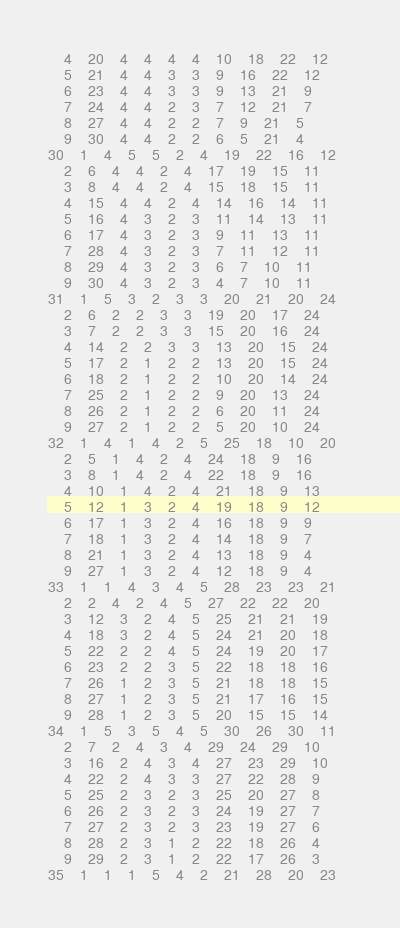<code> <loc_0><loc_0><loc_500><loc_500><_ObjectiveC_>	4	20	4	4	4	4	10	18	22	12	
	5	21	4	4	3	3	9	16	22	12	
	6	23	4	4	3	3	9	13	21	9	
	7	24	4	4	2	3	7	12	21	7	
	8	27	4	4	2	2	7	9	21	5	
	9	30	4	4	2	2	6	5	21	4	
30	1	4	5	5	2	4	19	22	16	12	
	2	6	4	4	2	4	17	19	15	11	
	3	8	4	4	2	4	15	18	15	11	
	4	15	4	4	2	4	14	16	14	11	
	5	16	4	3	2	3	11	14	13	11	
	6	17	4	3	2	3	9	11	13	11	
	7	28	4	3	2	3	7	11	12	11	
	8	29	4	3	2	3	6	7	10	11	
	9	30	4	3	2	3	4	7	10	11	
31	1	5	3	2	3	3	20	21	20	24	
	2	6	2	2	3	3	19	20	17	24	
	3	7	2	2	3	3	15	20	16	24	
	4	14	2	2	3	3	13	20	15	24	
	5	17	2	1	2	2	13	20	15	24	
	6	18	2	1	2	2	10	20	14	24	
	7	25	2	1	2	2	9	20	13	24	
	8	26	2	1	2	2	6	20	11	24	
	9	27	2	1	2	2	5	20	10	24	
32	1	4	1	4	2	5	25	18	10	20	
	2	5	1	4	2	4	24	18	9	16	
	3	8	1	4	2	4	22	18	9	16	
	4	10	1	4	2	4	21	18	9	13	
	5	12	1	3	2	4	19	18	9	12	
	6	17	1	3	2	4	16	18	9	9	
	7	18	1	3	2	4	14	18	9	7	
	8	21	1	3	2	4	13	18	9	4	
	9	27	1	3	2	4	12	18	9	4	
33	1	1	4	3	4	5	28	23	23	21	
	2	2	4	2	4	5	27	22	22	20	
	3	12	3	2	4	5	25	21	21	19	
	4	18	3	2	4	5	24	21	20	18	
	5	22	2	2	4	5	24	19	20	17	
	6	23	2	2	3	5	22	18	18	16	
	7	26	1	2	3	5	21	18	18	15	
	8	27	1	2	3	5	21	17	16	15	
	9	28	1	2	3	5	20	15	15	14	
34	1	5	3	5	4	5	30	26	30	11	
	2	7	2	4	3	4	29	24	29	10	
	3	16	2	4	3	4	27	23	29	10	
	4	22	2	4	3	3	27	22	28	9	
	5	25	2	3	2	3	25	20	27	8	
	6	26	2	3	2	3	24	19	27	7	
	7	27	2	3	2	3	23	19	27	6	
	8	28	2	3	1	2	22	18	26	4	
	9	29	2	3	1	2	22	17	26	3	
35	1	1	1	5	4	2	21	28	20	23	</code> 